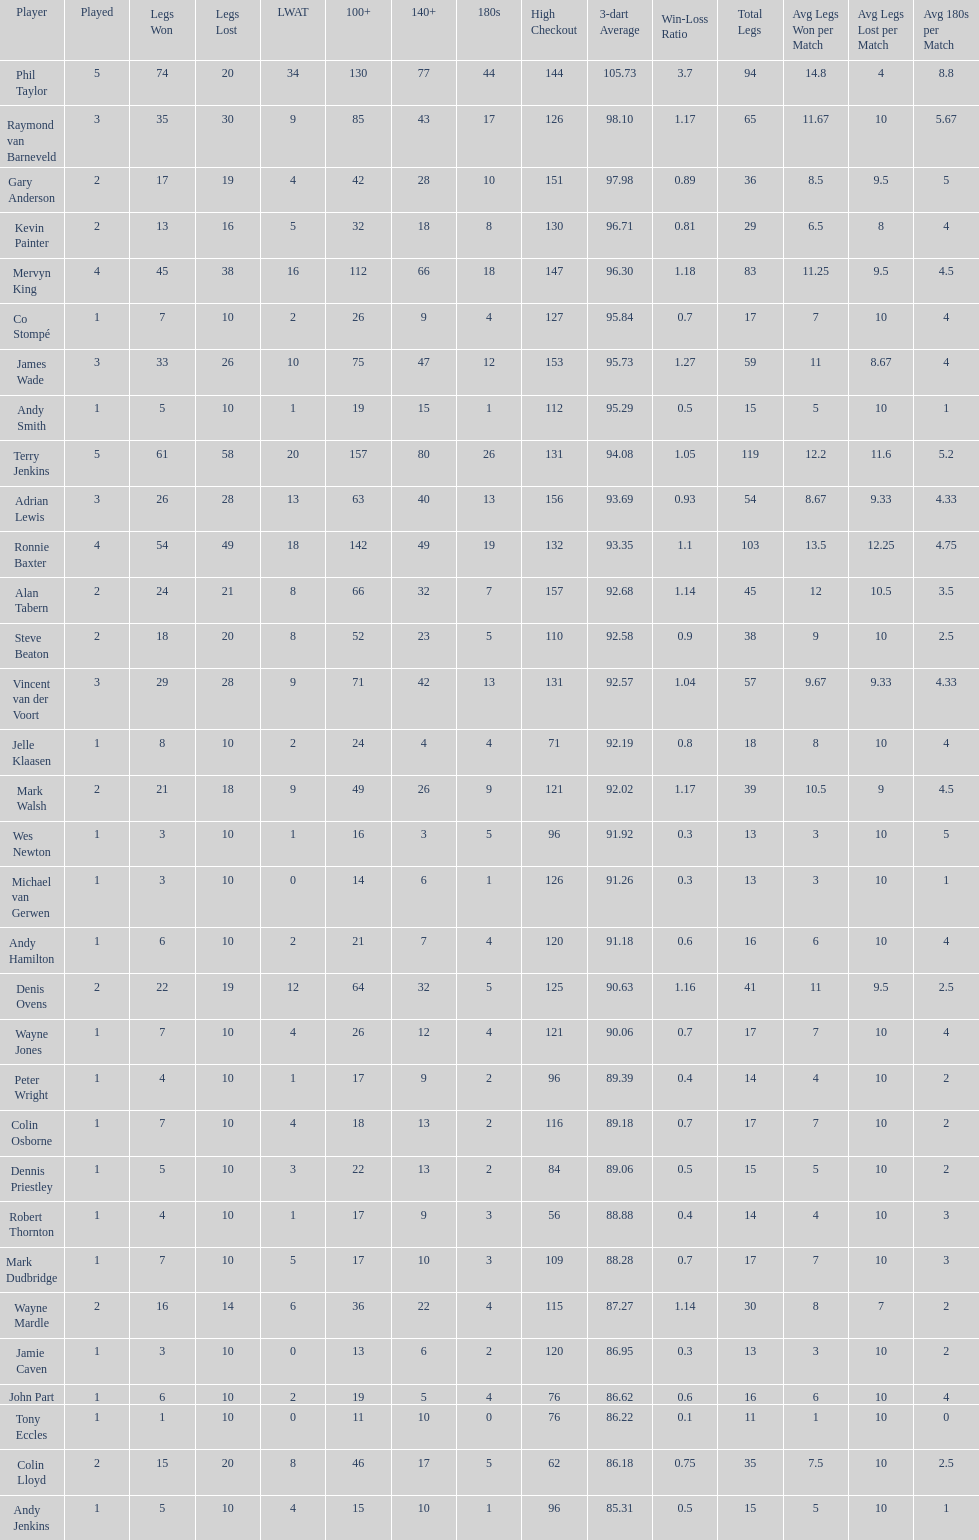Who won the highest number of legs in the 2009 world matchplay? Phil Taylor. 